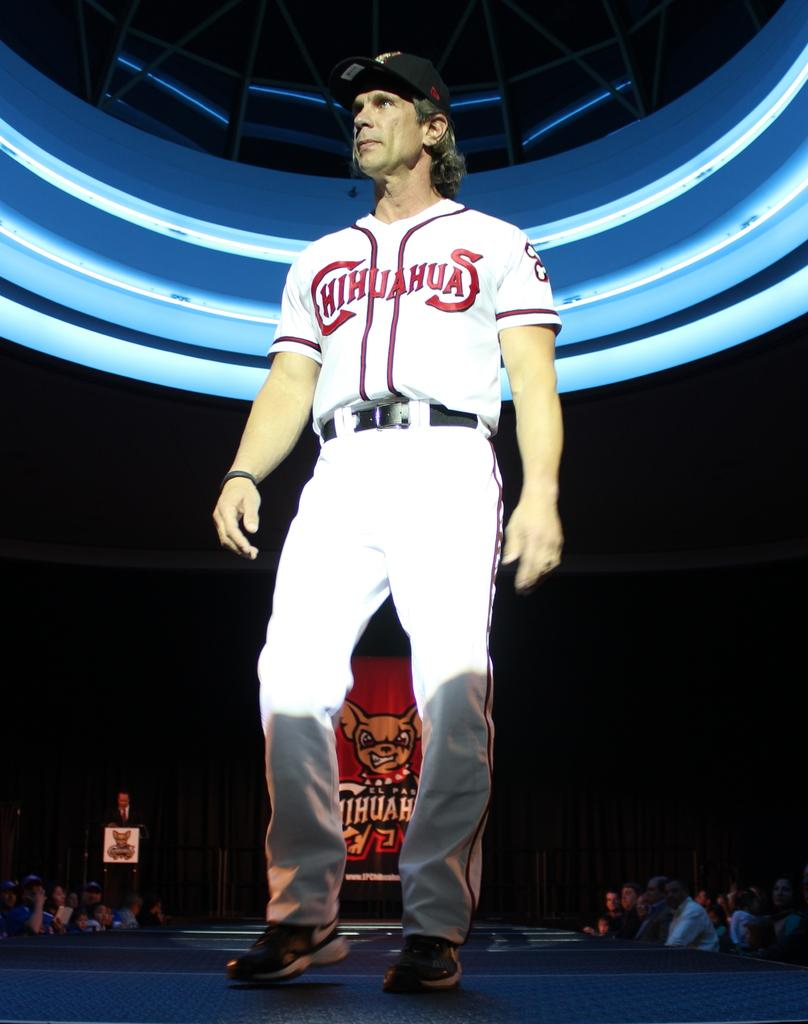<image>
Give a short and clear explanation of the subsequent image. One of the El Paso Chihuahuas players on stage 